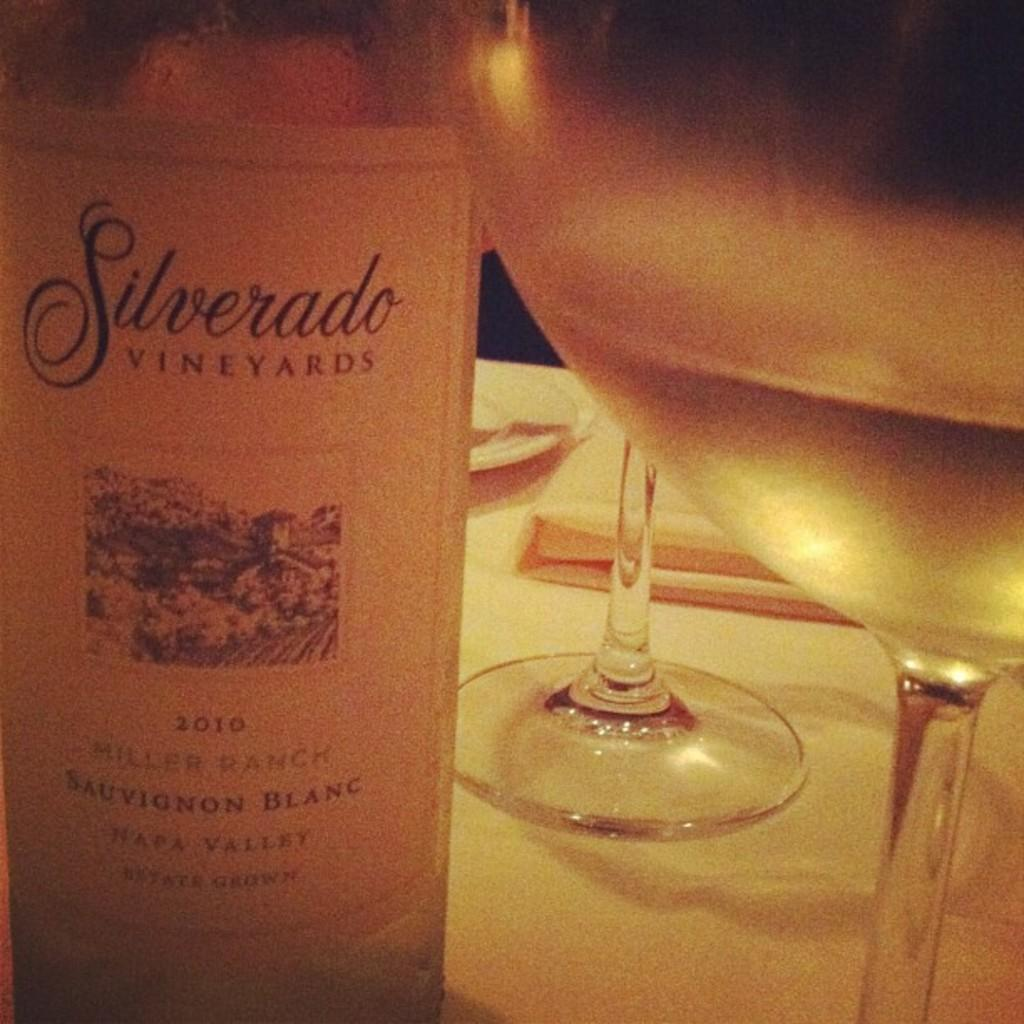What object is located on the left side of the image? There is a bottle on the left side of the image. What objects are on the right side of the image? There are glasses on the right side of the image. What piece of furniture is at the bottom of the image? There is a table at the bottom of the image. How many ladybugs can be seen crawling on the table in the image? There are no ladybugs present in the image; it only features a bottle, glasses, and a table. What type of line is visible on the glasses in the image? There is no line visible on the glasses in the image; they are simply glasses. 